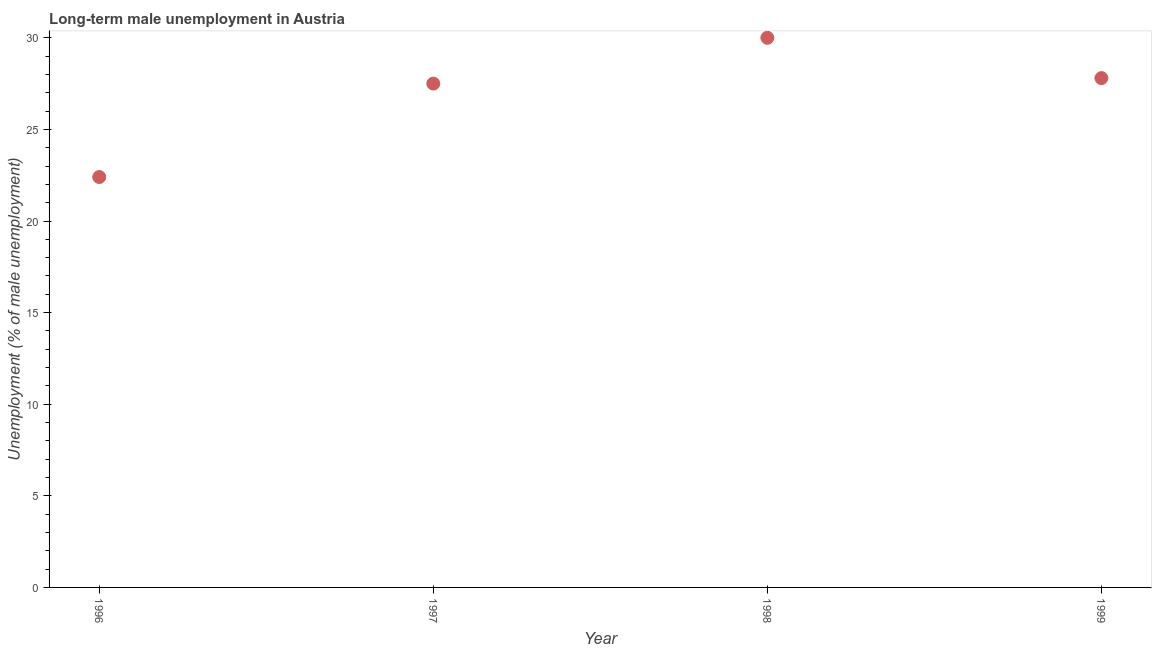What is the long-term male unemployment in 1999?
Your answer should be compact. 27.8. Across all years, what is the minimum long-term male unemployment?
Provide a succinct answer. 22.4. In which year was the long-term male unemployment maximum?
Make the answer very short. 1998. In which year was the long-term male unemployment minimum?
Your answer should be compact. 1996. What is the sum of the long-term male unemployment?
Your response must be concise. 107.7. What is the difference between the long-term male unemployment in 1996 and 1999?
Your response must be concise. -5.4. What is the average long-term male unemployment per year?
Your answer should be compact. 26.92. What is the median long-term male unemployment?
Your answer should be compact. 27.65. In how many years, is the long-term male unemployment greater than 23 %?
Your answer should be very brief. 3. What is the ratio of the long-term male unemployment in 1996 to that in 1998?
Your response must be concise. 0.75. Is the long-term male unemployment in 1998 less than that in 1999?
Keep it short and to the point. No. What is the difference between the highest and the second highest long-term male unemployment?
Keep it short and to the point. 2.2. What is the difference between the highest and the lowest long-term male unemployment?
Make the answer very short. 7.6. How many years are there in the graph?
Provide a succinct answer. 4. Does the graph contain any zero values?
Ensure brevity in your answer.  No. What is the title of the graph?
Offer a terse response. Long-term male unemployment in Austria. What is the label or title of the Y-axis?
Your response must be concise. Unemployment (% of male unemployment). What is the Unemployment (% of male unemployment) in 1996?
Your response must be concise. 22.4. What is the Unemployment (% of male unemployment) in 1997?
Ensure brevity in your answer.  27.5. What is the Unemployment (% of male unemployment) in 1999?
Ensure brevity in your answer.  27.8. What is the difference between the Unemployment (% of male unemployment) in 1996 and 1998?
Give a very brief answer. -7.6. What is the difference between the Unemployment (% of male unemployment) in 1996 and 1999?
Offer a very short reply. -5.4. What is the ratio of the Unemployment (% of male unemployment) in 1996 to that in 1997?
Provide a short and direct response. 0.81. What is the ratio of the Unemployment (% of male unemployment) in 1996 to that in 1998?
Your answer should be compact. 0.75. What is the ratio of the Unemployment (% of male unemployment) in 1996 to that in 1999?
Keep it short and to the point. 0.81. What is the ratio of the Unemployment (% of male unemployment) in 1997 to that in 1998?
Make the answer very short. 0.92. What is the ratio of the Unemployment (% of male unemployment) in 1997 to that in 1999?
Ensure brevity in your answer.  0.99. What is the ratio of the Unemployment (% of male unemployment) in 1998 to that in 1999?
Offer a terse response. 1.08. 